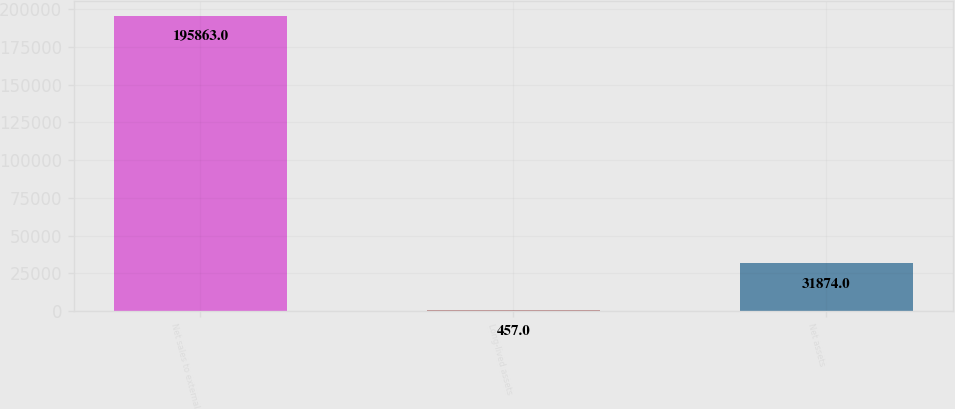Convert chart. <chart><loc_0><loc_0><loc_500><loc_500><bar_chart><fcel>Net sales to external<fcel>Long-lived assets<fcel>Net assets<nl><fcel>195863<fcel>457<fcel>31874<nl></chart> 